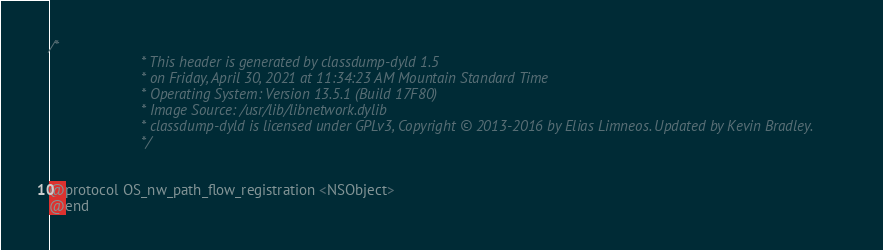Convert code to text. <code><loc_0><loc_0><loc_500><loc_500><_C_>/*
                       * This header is generated by classdump-dyld 1.5
                       * on Friday, April 30, 2021 at 11:34:23 AM Mountain Standard Time
                       * Operating System: Version 13.5.1 (Build 17F80)
                       * Image Source: /usr/lib/libnetwork.dylib
                       * classdump-dyld is licensed under GPLv3, Copyright © 2013-2016 by Elias Limneos. Updated by Kevin Bradley.
                       */


@protocol OS_nw_path_flow_registration <NSObject>
@end

</code> 